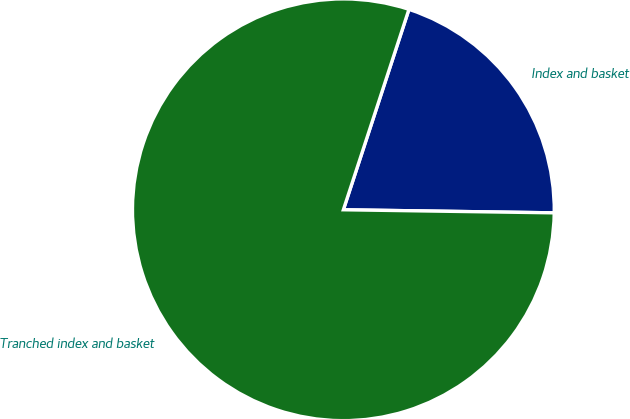Convert chart to OTSL. <chart><loc_0><loc_0><loc_500><loc_500><pie_chart><fcel>Index and basket<fcel>Tranched index and basket<nl><fcel>20.2%<fcel>79.8%<nl></chart> 